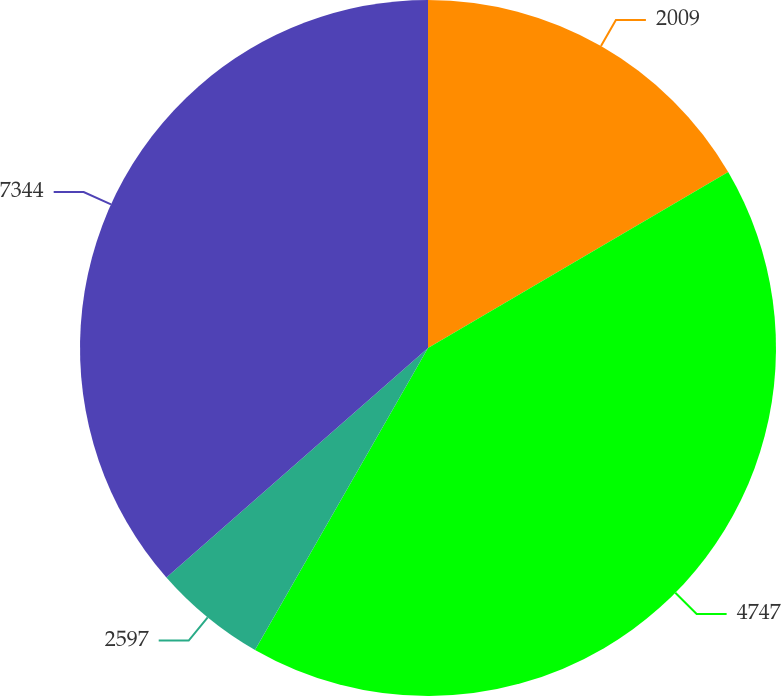Convert chart. <chart><loc_0><loc_0><loc_500><loc_500><pie_chart><fcel>2009<fcel>4747<fcel>2597<fcel>7344<nl><fcel>16.56%<fcel>41.72%<fcel>5.26%<fcel>36.46%<nl></chart> 